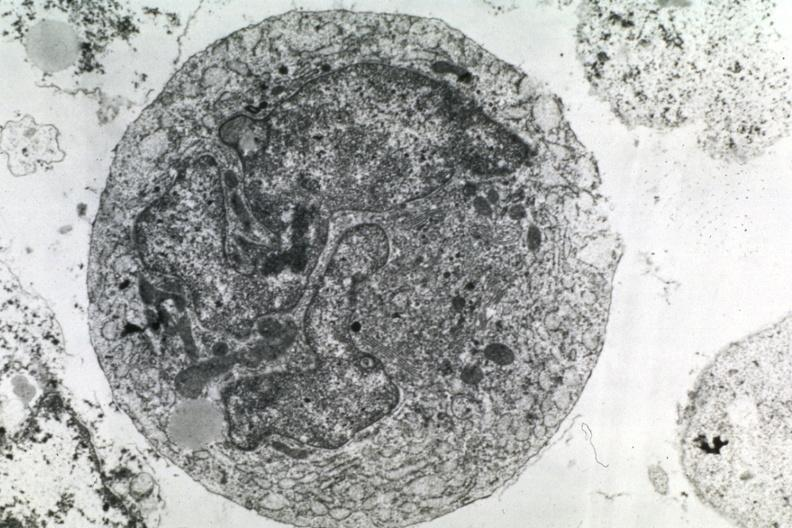what is present?
Answer the question using a single word or phrase. Lymphoma 